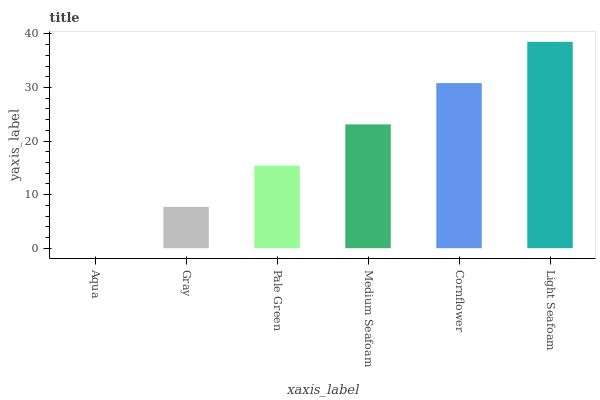Is Aqua the minimum?
Answer yes or no. Yes. Is Light Seafoam the maximum?
Answer yes or no. Yes. Is Gray the minimum?
Answer yes or no. No. Is Gray the maximum?
Answer yes or no. No. Is Gray greater than Aqua?
Answer yes or no. Yes. Is Aqua less than Gray?
Answer yes or no. Yes. Is Aqua greater than Gray?
Answer yes or no. No. Is Gray less than Aqua?
Answer yes or no. No. Is Medium Seafoam the high median?
Answer yes or no. Yes. Is Pale Green the low median?
Answer yes or no. Yes. Is Gray the high median?
Answer yes or no. No. Is Cornflower the low median?
Answer yes or no. No. 